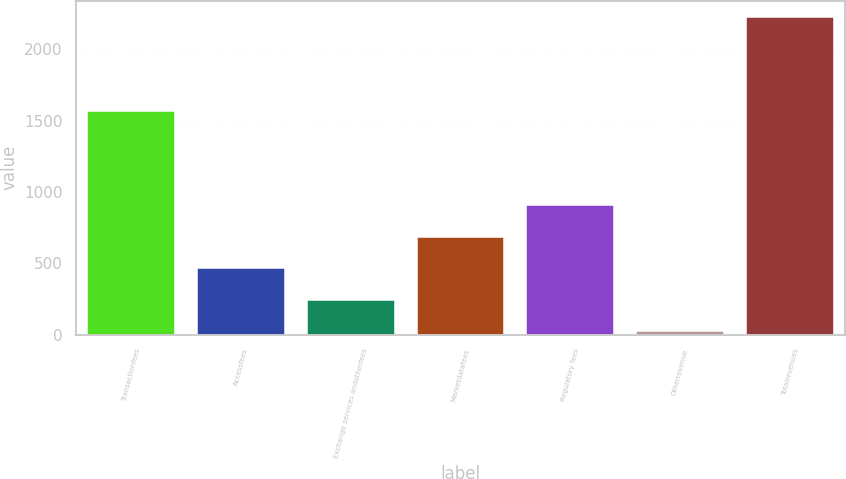<chart> <loc_0><loc_0><loc_500><loc_500><bar_chart><fcel>Transactionfees<fcel>Accessfees<fcel>Exchange services andotherfees<fcel>Marketdatafees<fcel>Regulatory fees<fcel>Otherrevenue<fcel>Totalrevenues<nl><fcel>1564.9<fcel>467.1<fcel>246.85<fcel>687.35<fcel>907.6<fcel>26.6<fcel>2229.1<nl></chart> 